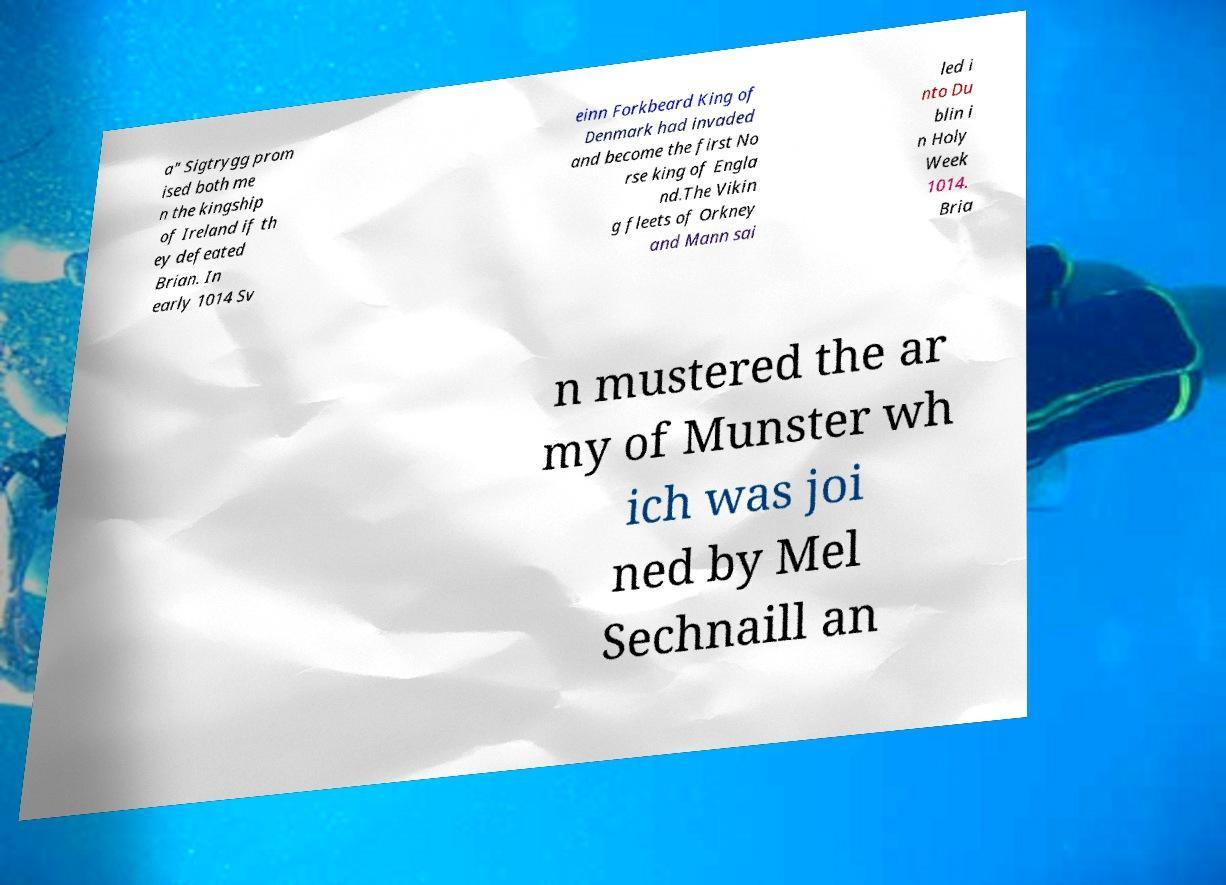I need the written content from this picture converted into text. Can you do that? a" Sigtrygg prom ised both me n the kingship of Ireland if th ey defeated Brian. In early 1014 Sv einn Forkbeard King of Denmark had invaded and become the first No rse king of Engla nd.The Vikin g fleets of Orkney and Mann sai led i nto Du blin i n Holy Week 1014. Bria n mustered the ar my of Munster wh ich was joi ned by Mel Sechnaill an 